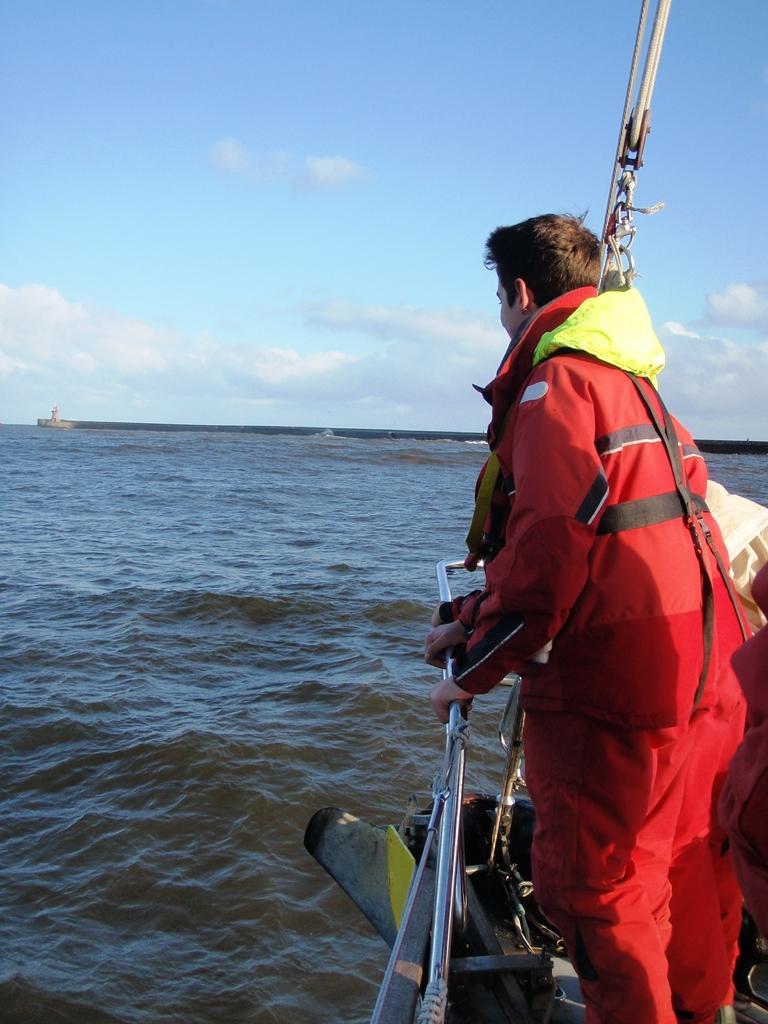How would you summarize this image in a sentence or two? In this picture, we can see a person in a swimsuit sailing in a boat, and we can see water, lighthouse and the sky with clouds, and we can see some objects in the top right corner. 